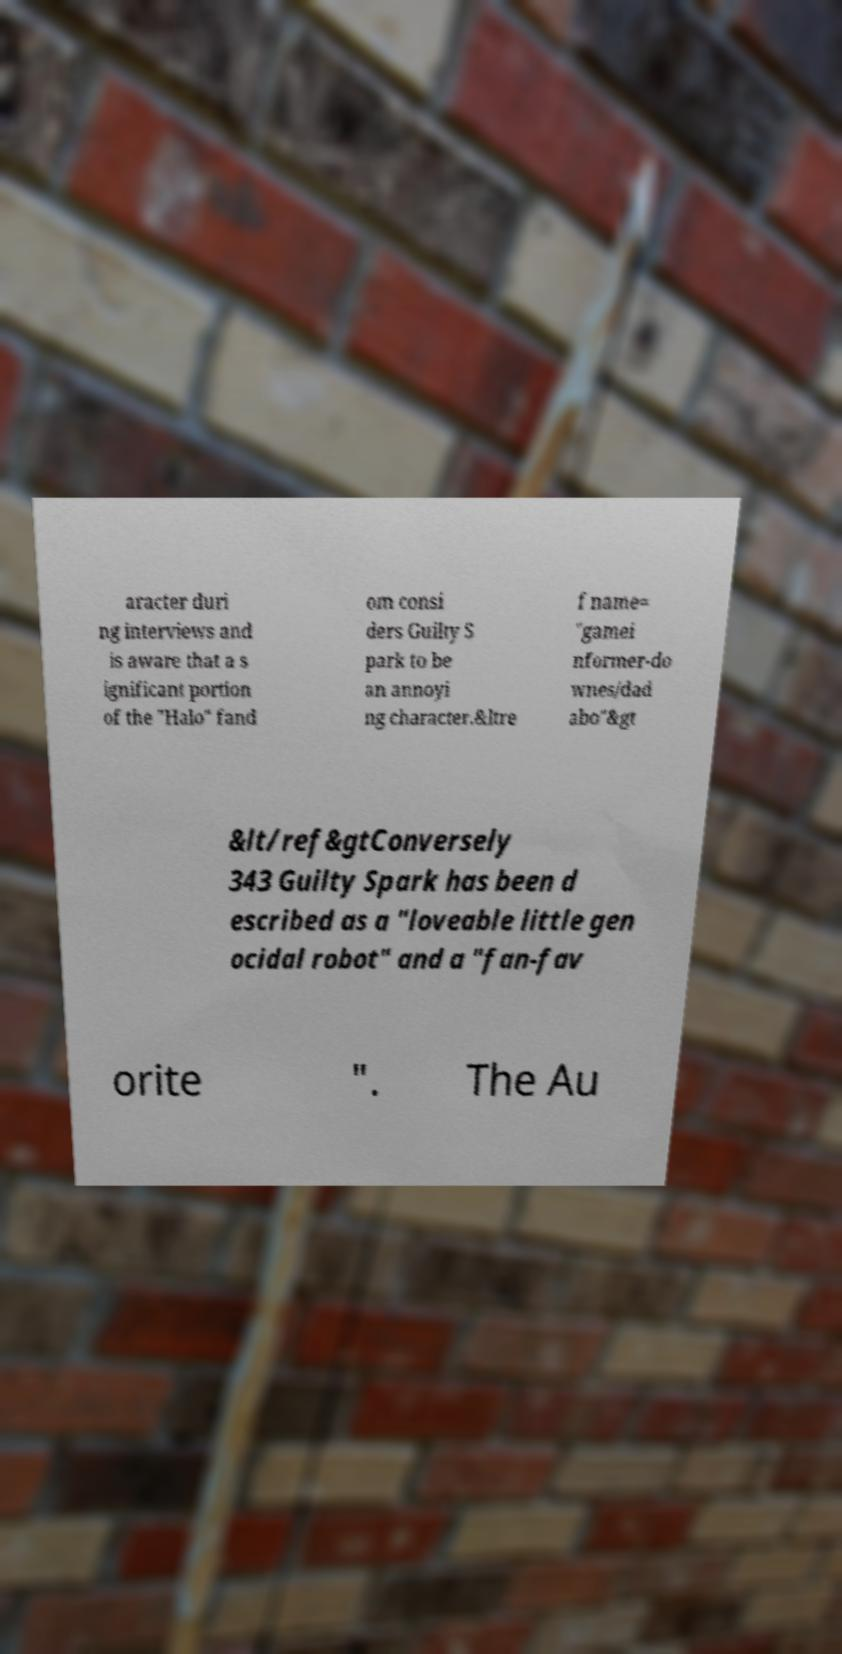Please identify and transcribe the text found in this image. aracter duri ng interviews and is aware that a s ignificant portion of the "Halo" fand om consi ders Guilty S park to be an annoyi ng character.&ltre f name= "gamei nformer-do wnes/dad abo"&gt &lt/ref&gtConversely 343 Guilty Spark has been d escribed as a "loveable little gen ocidal robot" and a "fan-fav orite ". The Au 